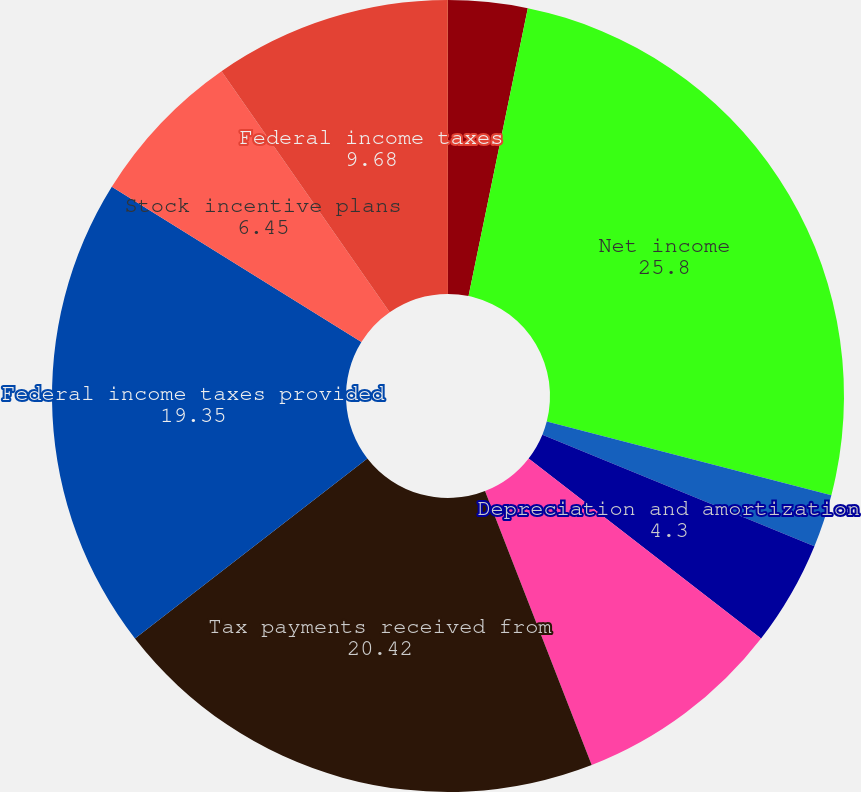Convert chart. <chart><loc_0><loc_0><loc_500><loc_500><pie_chart><fcel>(In thousands)<fcel>Net income<fcel>Net investment gains<fcel>Depreciation and amortization<fcel>Equity in undistributed<fcel>Tax payments received from<fcel>Federal income taxes provided<fcel>Stock incentive plans<fcel>Federal income taxes<fcel>Other assets<nl><fcel>3.23%<fcel>25.8%<fcel>2.16%<fcel>4.3%<fcel>8.6%<fcel>20.42%<fcel>19.35%<fcel>6.45%<fcel>9.68%<fcel>0.01%<nl></chart> 